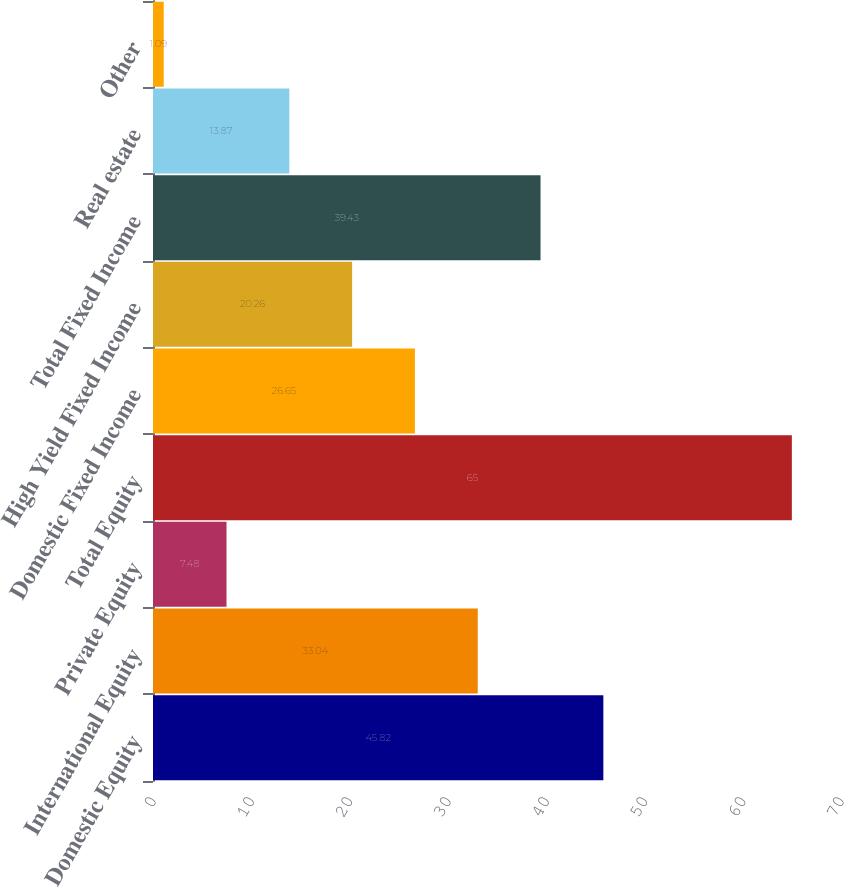<chart> <loc_0><loc_0><loc_500><loc_500><bar_chart><fcel>Domestic Equity<fcel>International Equity<fcel>Private Equity<fcel>Total Equity<fcel>Domestic Fixed Income<fcel>High Yield Fixed Income<fcel>Total Fixed Income<fcel>Real estate<fcel>Other<nl><fcel>45.82<fcel>33.04<fcel>7.48<fcel>65<fcel>26.65<fcel>20.26<fcel>39.43<fcel>13.87<fcel>1.09<nl></chart> 